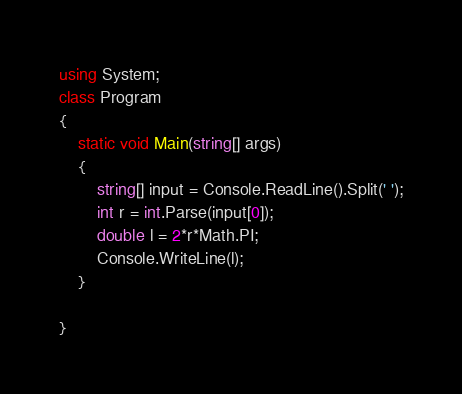<code> <loc_0><loc_0><loc_500><loc_500><_C#_>using System;
class Program
{
	static void Main(string[] args)
	{
		string[] input = Console.ReadLine().Split(' ');
        int r = int.Parse(input[0]);
        double l = 2*r*Math.PI;
        Console.WriteLine(l);
	}

}</code> 